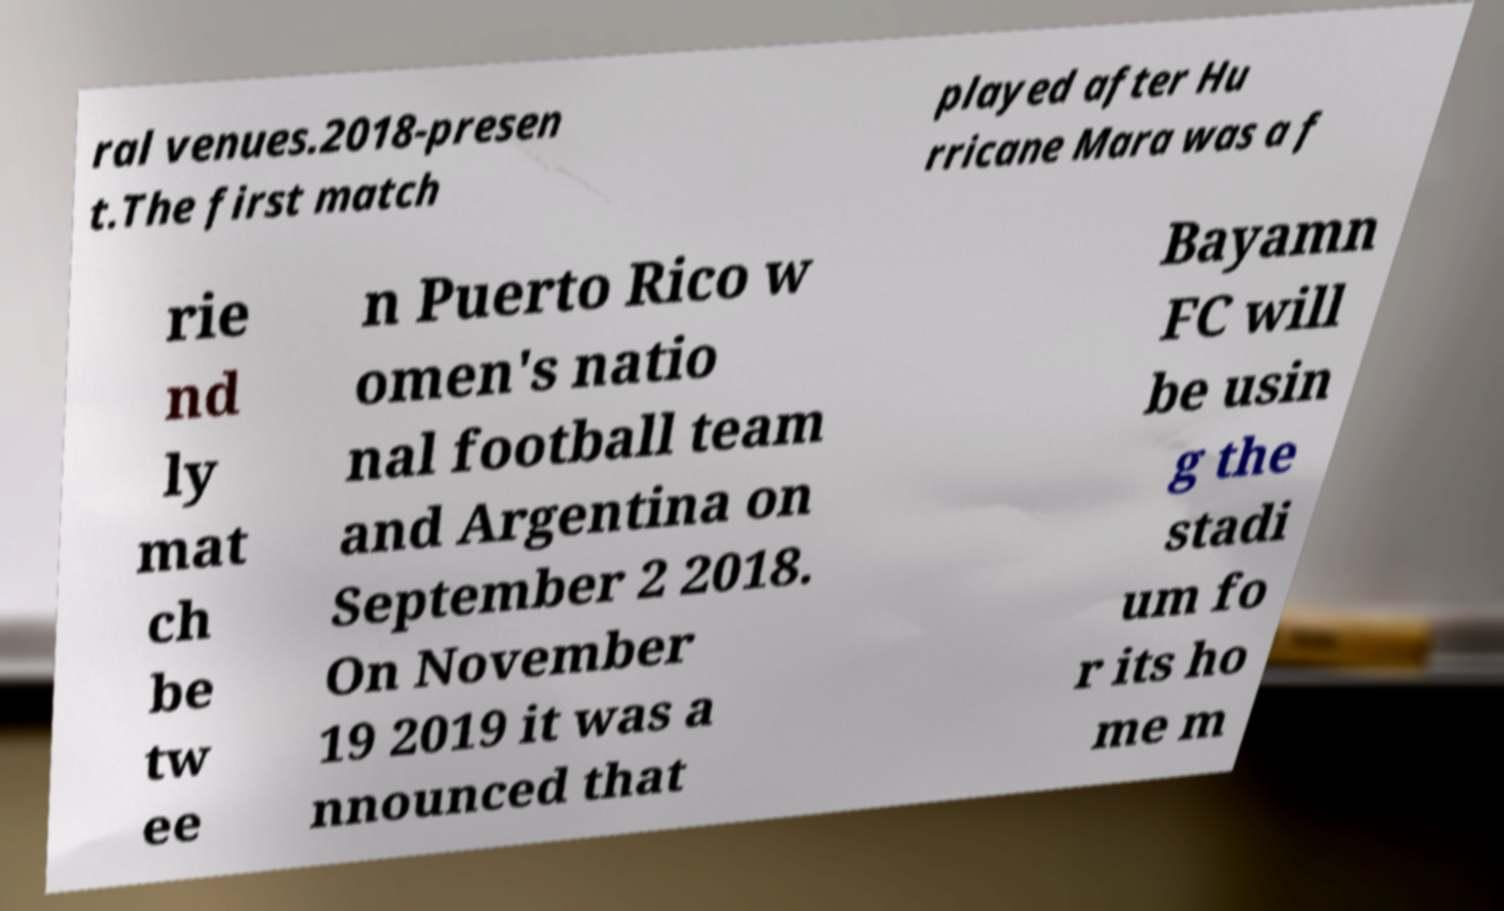Could you extract and type out the text from this image? ral venues.2018-presen t.The first match played after Hu rricane Mara was a f rie nd ly mat ch be tw ee n Puerto Rico w omen's natio nal football team and Argentina on September 2 2018. On November 19 2019 it was a nnounced that Bayamn FC will be usin g the stadi um fo r its ho me m 